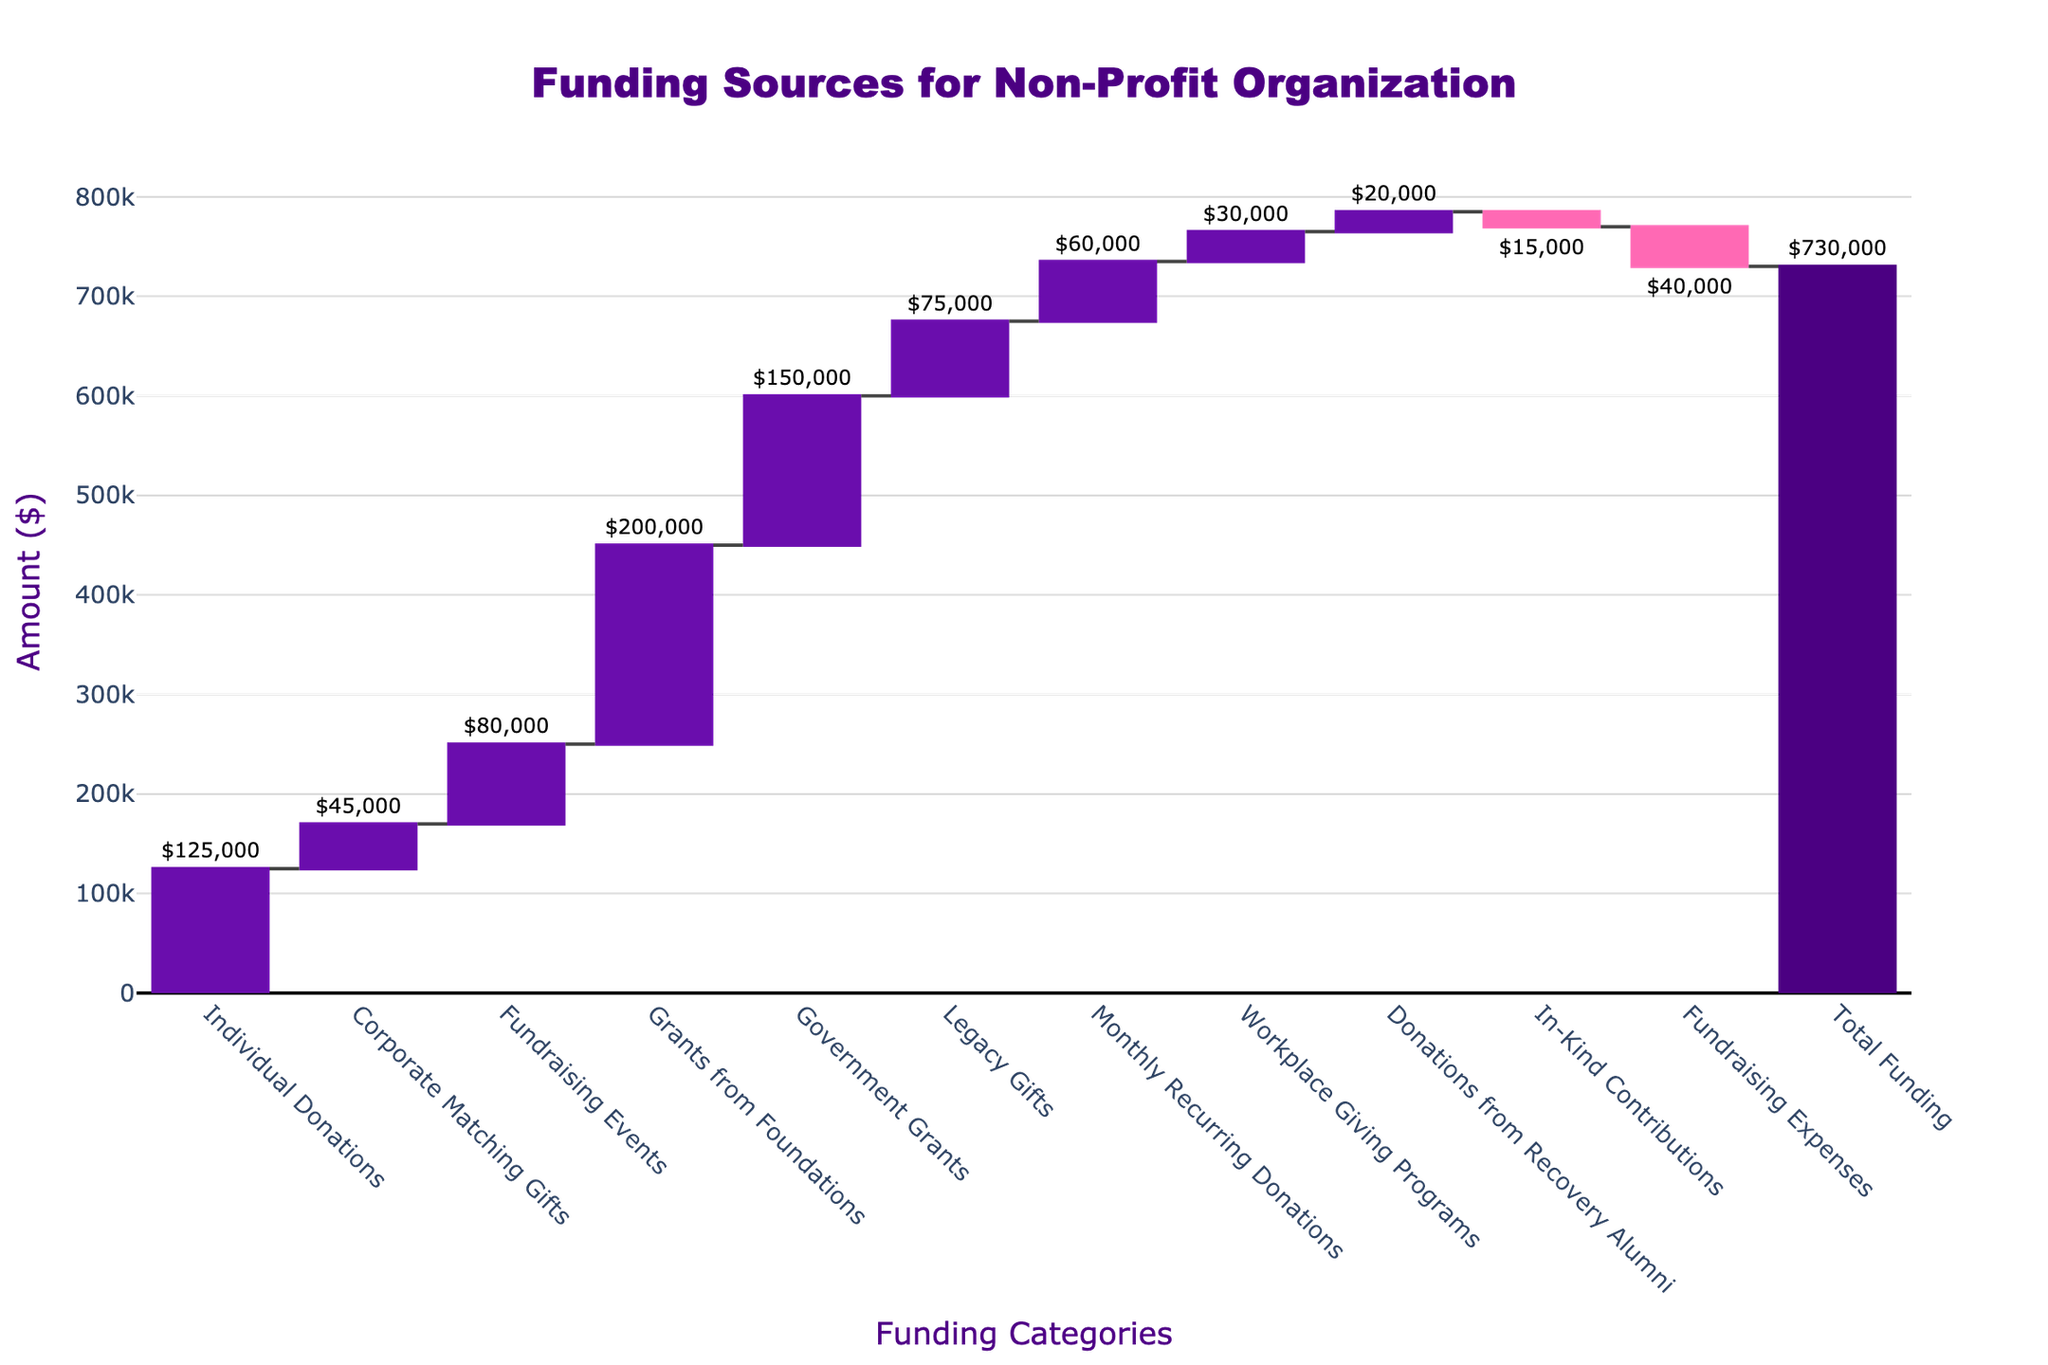what is the title of the plot? The title is located at the top center of the chart and usually describes the main topic of the visualization. Here, it reads 'Funding Sources for Non-Profit Organization'.
Answer: Funding Sources for Non-Profit Organization How many funding categories are displayed in the chart? The chart includes individual bars with labels representing each funding category. By counting these labels, we identify a total of 11 categories plus the 'Total Funding'.
Answer: 11 Which funding source contributed the most to the organization? By comparing the heights of the bars representing each funding category, the 'Grants from Foundations' has the highest bar, which means it contributed the most.
Answer: Grants from Foundations How much did 'Individual Donations' contribute to the funding? The bar labeled 'Individual Donations' shows an upward movement with text "$125,000" displayed. This indicates the amount contributed by 'Individual Donations'.
Answer: $125,000 Which funding source has a negative contribution, and what is its value? Negative contributions are represented by bars moving downward. 'In-Kind Contributions' shows such a bar, with the value labeled "-$15,000".
Answer: In-Kind Contributions, -$15,000 What's the total amount of funding after considering all categories? The last bar represents 'Total Funding' and shows the net effect after combining all positive and negative contributions. This bar is labeled with the total "$730,000".
Answer: $730,000 Which categories have contributions less than $50,000? By examining each bar, we find that 'Corporate Matching Gifts' ($45,000), 'Workplace Giving Programs' ($30,000), 'Donations from Recovery Alumni' ($20,000), and 'In-Kind Contributions' (-$15,000) have contributions under $50,000.
Answer: Corporate Matching Gifts, Workplace Giving Programs, Donations from Recovery Alumni, In-Kind Contributions What is the net difference between 'Government Grants' and 'Legacy Gifts'? 'Government Grants' contributed $150,000 and 'Legacy Gifts' $75,000. The net difference is calculated as $150,000 - $75,000 = $75,000.
Answer: $75,000 Which funding source has the closest contribution value to $80,000? By comparing each bar's value, 'Fundraising Events' has a contribution of $80,000, which exactly matches the given amount.
Answer: Fundraising Events Explain the total contributions of funding sources with negative values subtracted from the total amount. The negative contributions are 'In-Kind Contributions' (-$15,000) and 'Fundraising Expenses' (-$40,000). Summing them up: -$15,000 + -$40,000 = -$55,000. Subtracting this from the 'Total Funding' of $730,000: $730,000 + $55,000 = $785,000 total positive contributions before considering these negative values.
Answer: $785,000 